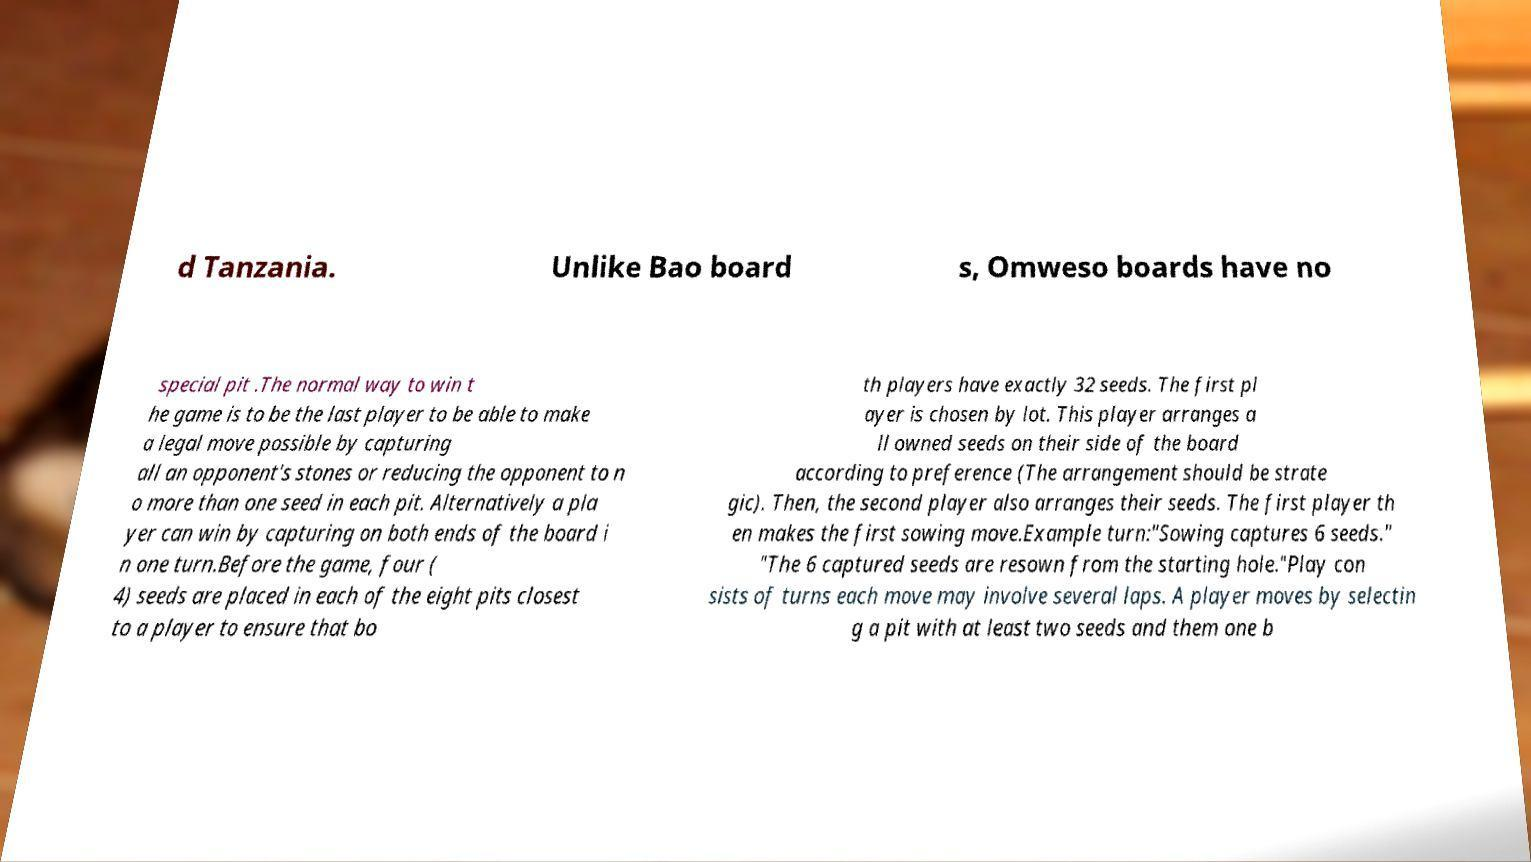For documentation purposes, I need the text within this image transcribed. Could you provide that? d Tanzania. Unlike Bao board s, Omweso boards have no special pit .The normal way to win t he game is to be the last player to be able to make a legal move possible by capturing all an opponent's stones or reducing the opponent to n o more than one seed in each pit. Alternatively a pla yer can win by capturing on both ends of the board i n one turn.Before the game, four ( 4) seeds are placed in each of the eight pits closest to a player to ensure that bo th players have exactly 32 seeds. The first pl ayer is chosen by lot. This player arranges a ll owned seeds on their side of the board according to preference (The arrangement should be strate gic). Then, the second player also arranges their seeds. The first player th en makes the first sowing move.Example turn:"Sowing captures 6 seeds." "The 6 captured seeds are resown from the starting hole."Play con sists of turns each move may involve several laps. A player moves by selectin g a pit with at least two seeds and them one b 